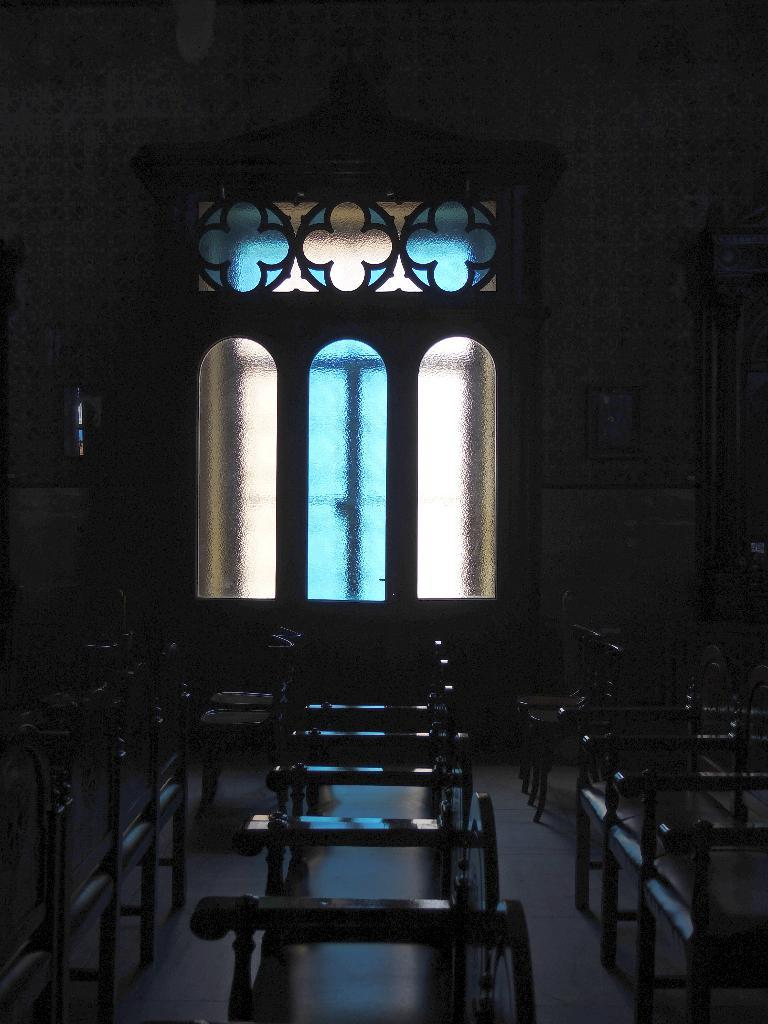What type of furniture is present in the image? There are many chairs in the image. What can be seen through the window in the image? The window has glass, but the specific view is not mentioned in the facts. What type of structure is visible in the image? There is a wall in the image. What type of shoe is visible on the wall in the image? There is no shoe present on the wall in the image. What type of pen is being used to write on the chairs in the image? There is no pen or writing activity mentioned in the image. 